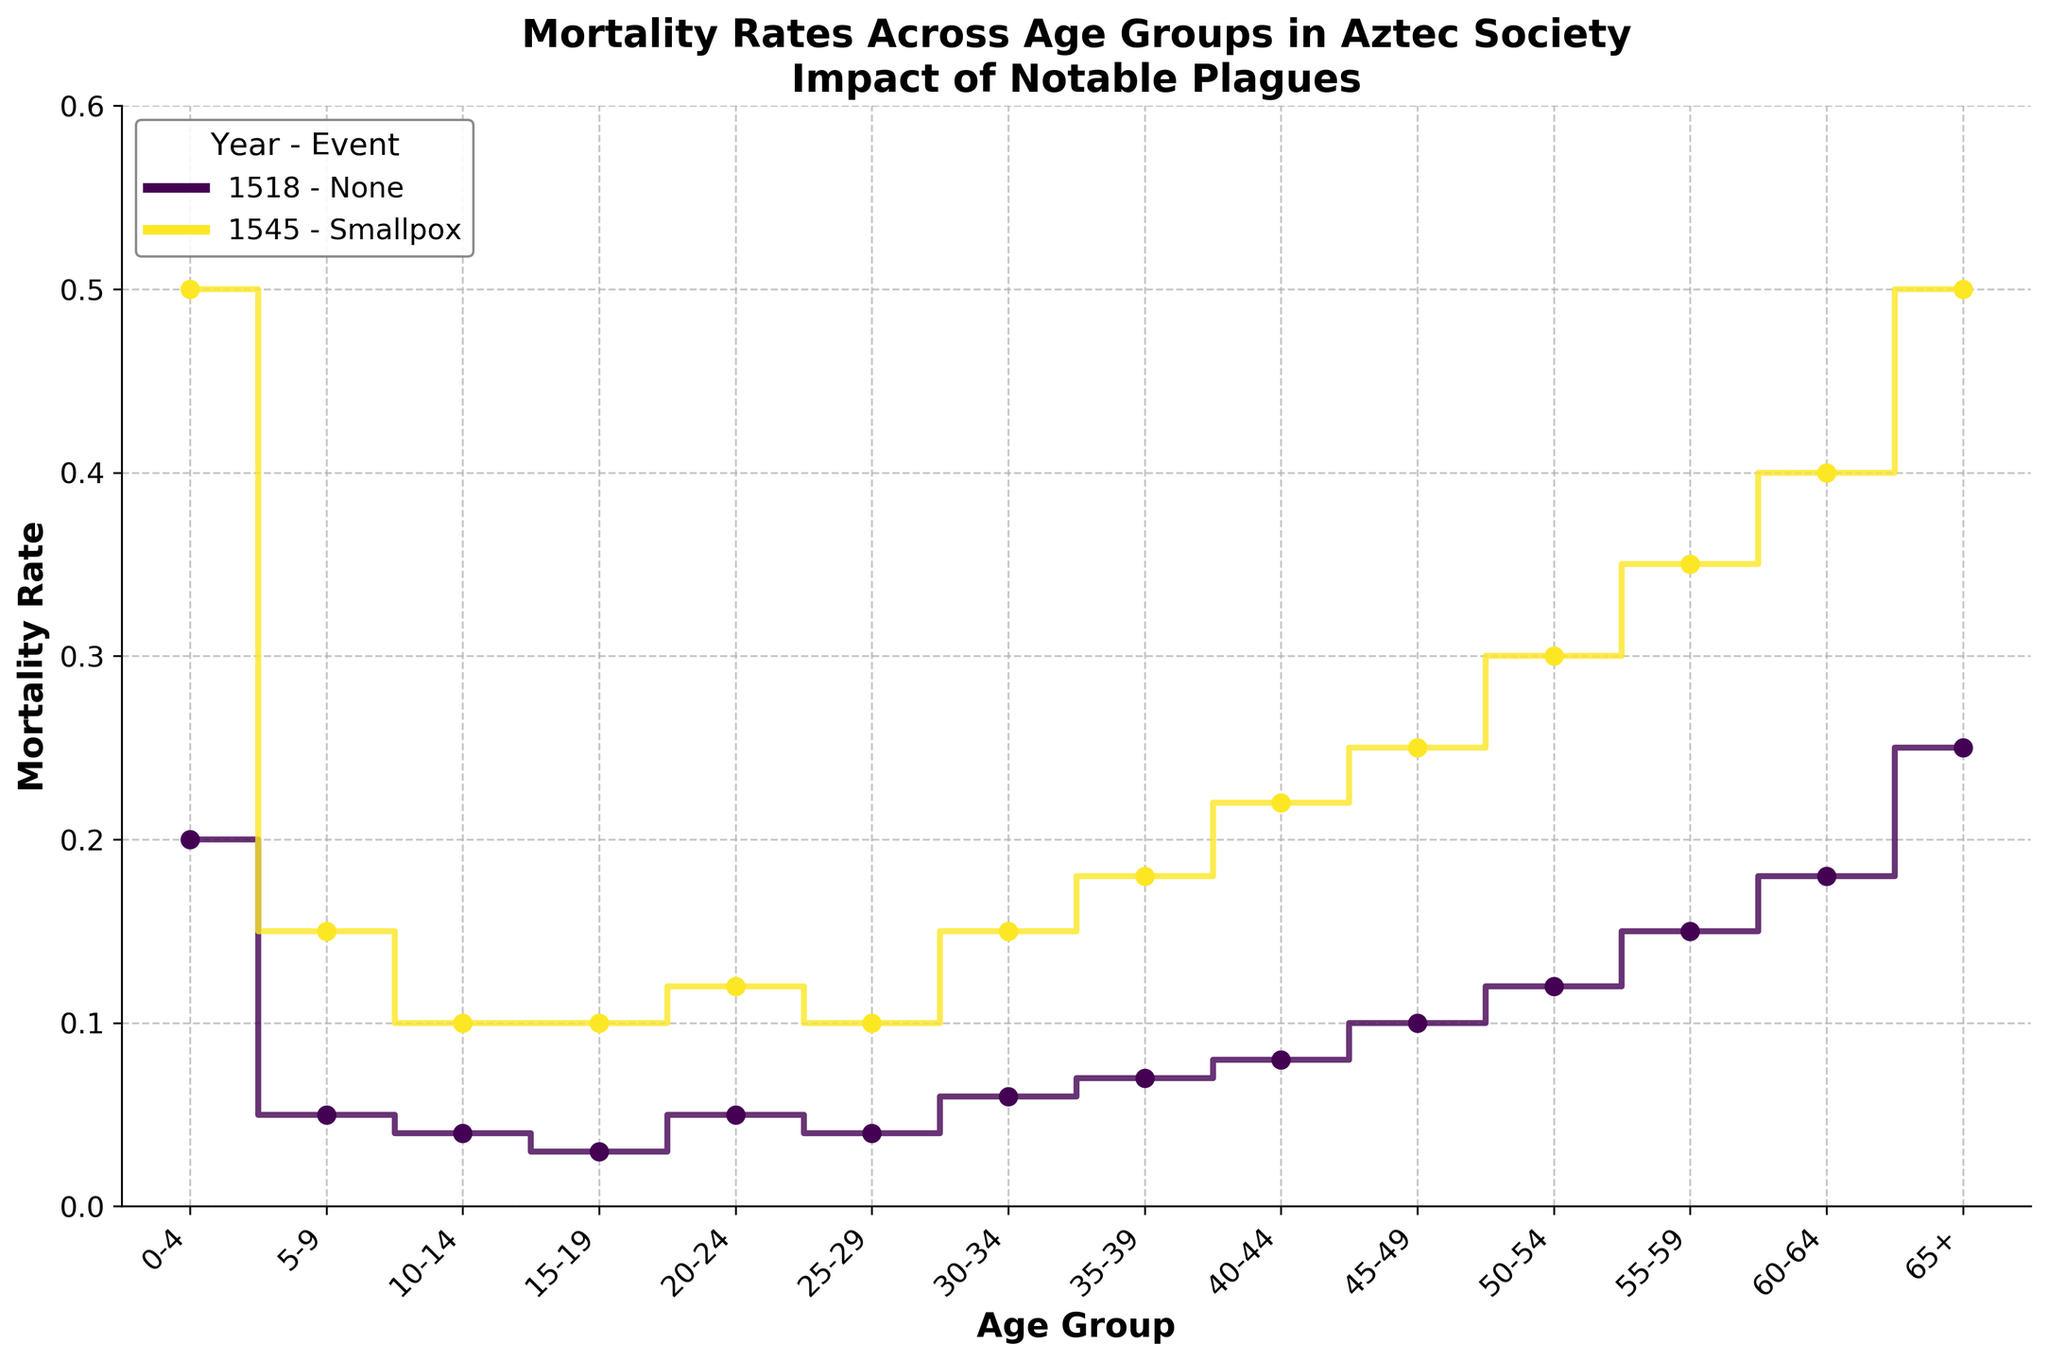What's the highest mortality rate observed in 1545? By examining the plotted data points for the year 1545, we find the highest mortality rate is at the furthest right, with a value of 0.5 for the 65+ age group.
Answer: 0.5 What's the average mortality rate for the age group 0-4 across both years shown? Mortality rates for 0-4 age group are 0.2 in 1518 and 0.5 in 1545. The average is calculated as (0.2 + 0.5) / 2 = 0.35.
Answer: 0.35 How did the mortality rate for the age group 20-24 change from 1518 to 1545? The mortality rate for the age group 20-24 in 1518 was 0.05. In 1545, it was 0.12. The rate increased by 0.07 from 1518 to 1545.
Answer: Increased by 0.07 Which age group experienced the highest increase in mortality rate due to the Smallpox plague in 1545? By comparing the mortality rates for each age group between 1518 and 1545, the 0-4 age group experienced the highest increase from 0.2 to 0.5, an increase of 0.3.
Answer: 0-4 Which year shows a higher overall mortality rate across all age groups? By comparing the plotted lines for each year, the overall trend shows that the mortality rates in 1545 are consistently higher than in 1518 across all age groups.
Answer: 1545 What was the mortality rate for the 35-39 age group in 1518? Looking at the plot for the year 1518, the mortality rate for the 35-39 age group is indicated around 0.07.
Answer: 0.07 In which age group was the mortality rate the lowest in 1545? By examining the scatter points for the year 1545, the lowest mortality rate is at the 10-14 and 15-19 age groups, both at 0.1.
Answer: 10-14 and 15-19 respectively Describe the general trend of mortality rates with age in 1518. The plot for 1518 shows a trend where mortality rates gradually increase with age, starting from 0.2 in the 0-4 age group and rising steadily up to 0.25 in the 65+ age group.
Answer: Increasing with age For the age group 50-54, which year had a higher mortality rate and by how much? Comparing the mortality rates for the 50-54 age group, 1518 had a rate of 0.12, whereas 1545 had a rate of 0.3. The increase from 1518 to 1545 is 0.18.
Answer: 1545 by 0.18 What is the visual difference in the plotted lines between the two years when looking at the 60-64 age group? For the 60-64 age group, the plot shows a mortality rate of 0.18 in 1518 and 0.4 in 1545. The line for 1545 rises more steeply at this age group compared to 1518.
Answer: 1545 rises more steeply 